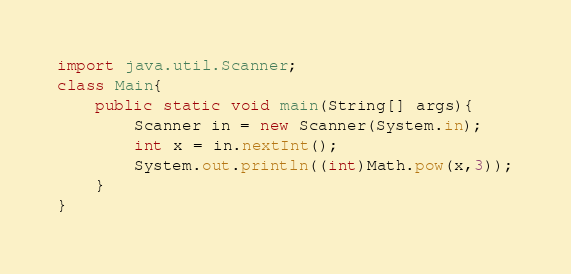<code> <loc_0><loc_0><loc_500><loc_500><_Java_>import java.util.Scanner;
class Main{
    public static void main(String[] args){
        Scanner in = new Scanner(System.in);
        int x = in.nextInt();
        System.out.println((int)Math.pow(x,3));
    }
}</code> 